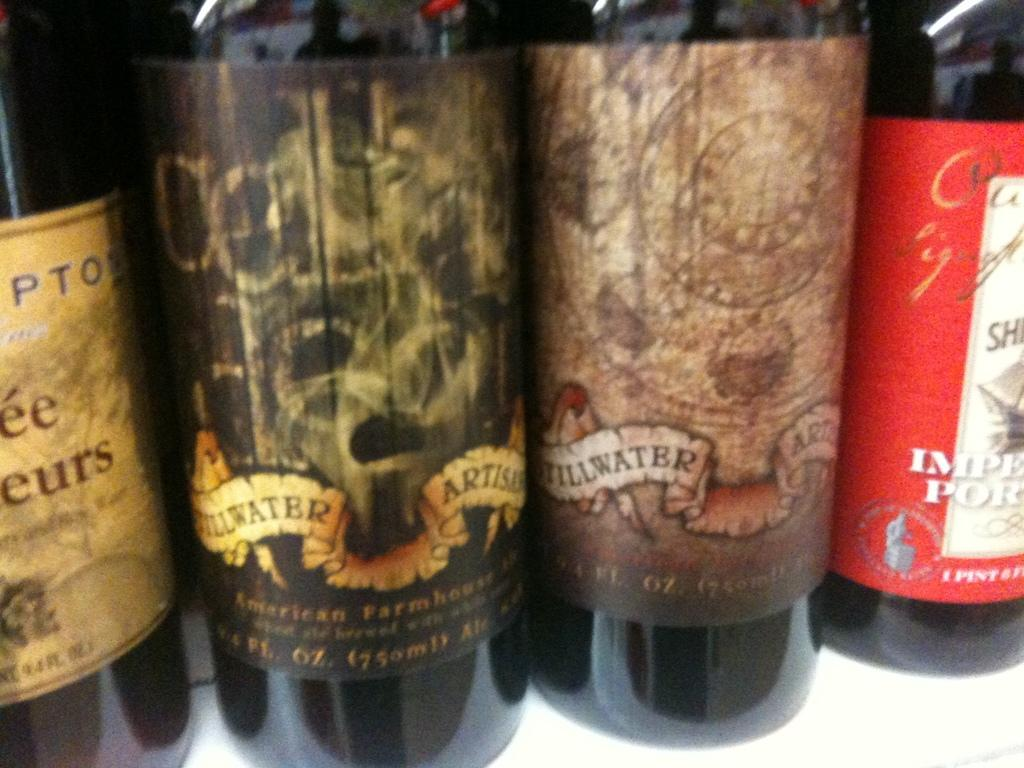<image>
Share a concise interpretation of the image provided. the word stillwater that is on a bottle 